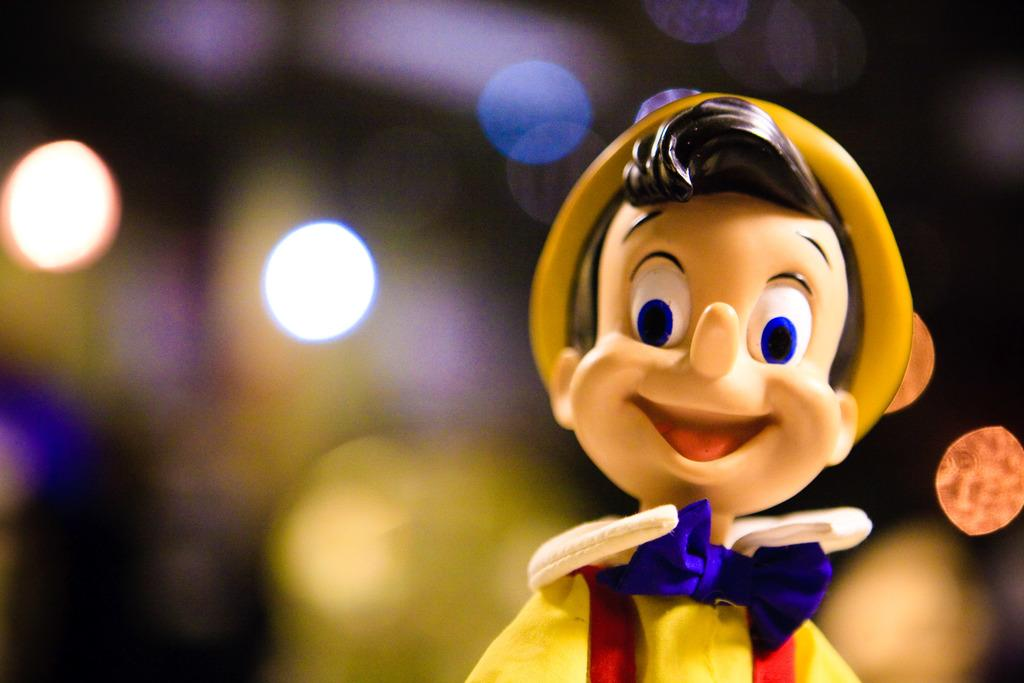What object can be seen in the image? There is a toy in the image. What can be seen in the background of the image? There are lights in the background of the image. What word is being spoken by the toy in the image? The toy in the image does not have the ability to speak, so there is no word being spoken. 